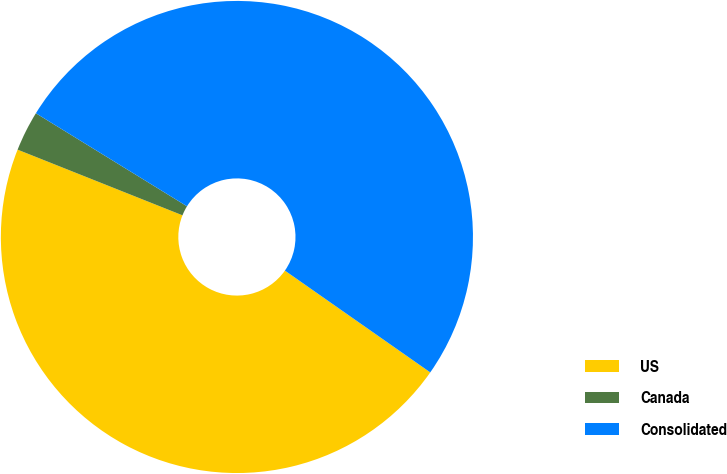<chart> <loc_0><loc_0><loc_500><loc_500><pie_chart><fcel>US<fcel>Canada<fcel>Consolidated<nl><fcel>46.31%<fcel>2.75%<fcel>50.94%<nl></chart> 